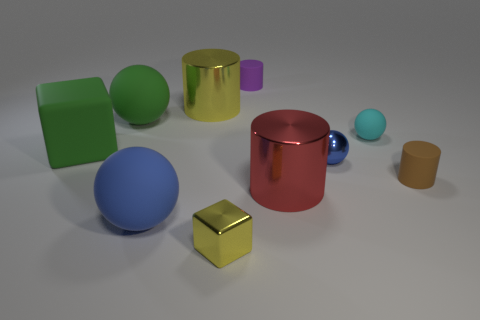Are there the same number of red cylinders in front of the small cyan sphere and blue spheres?
Offer a terse response. No. Are there any brown cylinders to the left of the rubber cylinder that is in front of the purple rubber cylinder?
Your answer should be compact. No. What number of other objects are the same color as the tiny metallic cube?
Provide a succinct answer. 1. What is the color of the big rubber block?
Provide a short and direct response. Green. What size is the rubber thing that is on the right side of the big blue ball and to the left of the tiny cyan matte ball?
Ensure brevity in your answer.  Small. What number of things are metallic objects to the left of the metallic cube or cyan rubber objects?
Give a very brief answer. 2. There is a blue object that is the same material as the large yellow cylinder; what is its shape?
Your answer should be compact. Sphere. What is the shape of the cyan thing?
Offer a terse response. Sphere. The ball that is both behind the blue shiny object and to the right of the green rubber ball is what color?
Provide a succinct answer. Cyan. What is the shape of the purple rubber thing that is the same size as the cyan ball?
Offer a very short reply. Cylinder. 